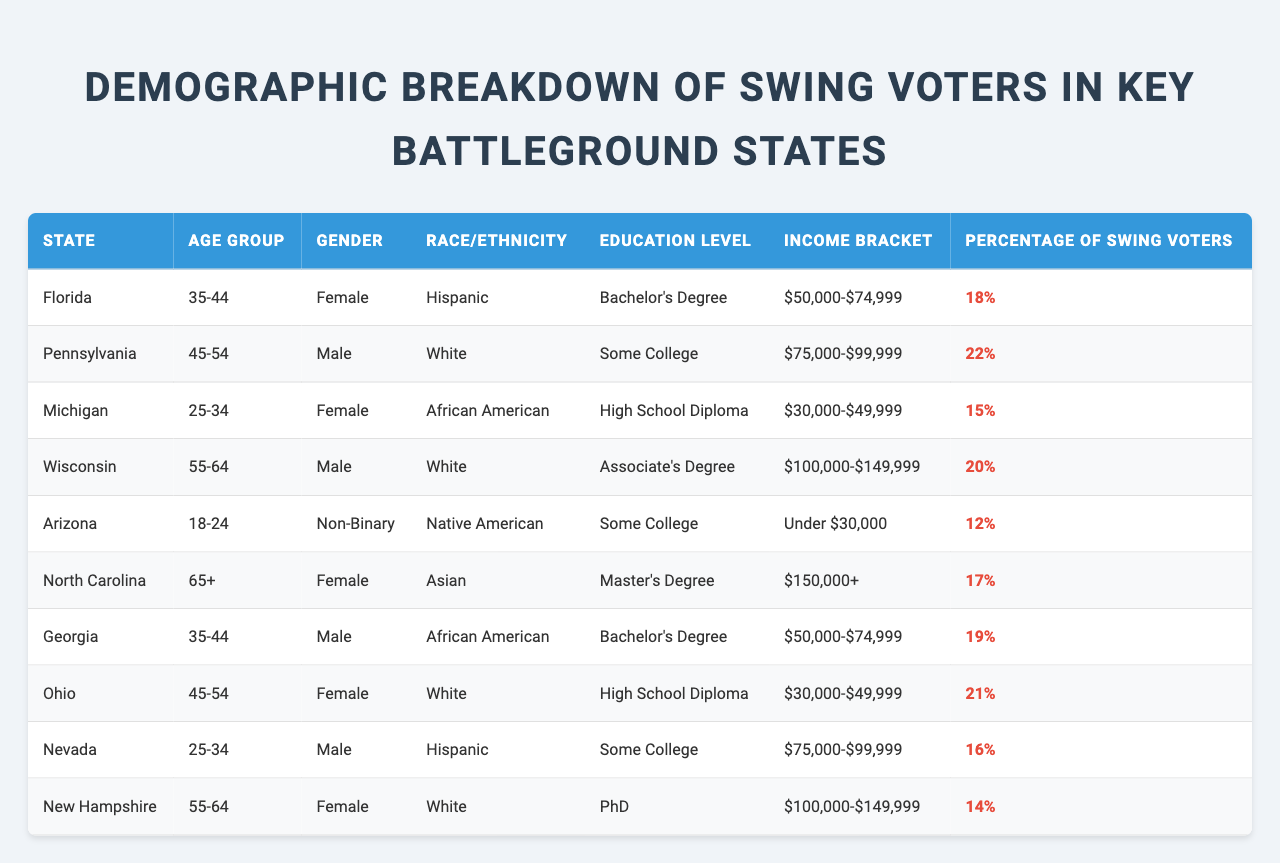What percentage of swing voters in Arizona are from the age group 18-24? The table indicates that in Arizona, the percentage of swing voters aged 18-24 is listed as 12%.
Answer: 12% Which state has the highest percentage of swing voters among males? By reviewing the table, Pennsylvania shows the highest percentage of swing voters among males at 22%.
Answer: Pennsylvania Is the percentage of swing voters in Michigan greater than the percentage in Nevada? The table shows 15% of swing voters in Michigan and 16% in Nevada, thus the statement is false.
Answer: No How many swing voters in North Carolina have a master's degree? According to the table, there is one entry for North Carolina with a master's degree, which corresponds to 17% of swing voters.
Answer: 17% What is the total percentage of swing voters in Florida and Pennsylvania? The percentage of swing voters in Florida is 18% and in Pennsylvania is 22%. Adding these gives 18 + 22 = 40%.
Answer: 40% Do all swing voters from North Carolina have an income bracket above $150,000? The table lists one entry for North Carolina showing that there is a swing voter with an income bracket of $150,000+, confirming that not all swing voters fit this income level since it’s the only entry.
Answer: Yes Which age group has the highest total percentage of swing voters in the table? If we compare age groups: "35-44" in Florida (18%), "45-54" in Pennsylvania (22%), "25-34" in Michigan (15%), and others, adding the highest values helps identify that "45-54" has the maximum at 22%.
Answer: 45-54 Are there more swing voters aged 55-64 in Wisconsin compared to New Hampshire? Wisconsin has 20% and New Hampshire has 14%, therefore Wisconsin has more swing voters in that age group.
Answer: Yes What is the average percentage of swing voters across all states represented in the table? We sum the percentages: 18 + 22 + 15 + 20 + 12 + 17 + 19 + 21 + 16 + 14 =  16.4. Dividing by the 10 states results in an average of 17.6%.
Answer: 17.6% Which race/ethnicity has the lowest percentage of swing voters based on the data? By comparing the races, Native American in Arizona has the lowest percentage at 12%.
Answer: Native American 